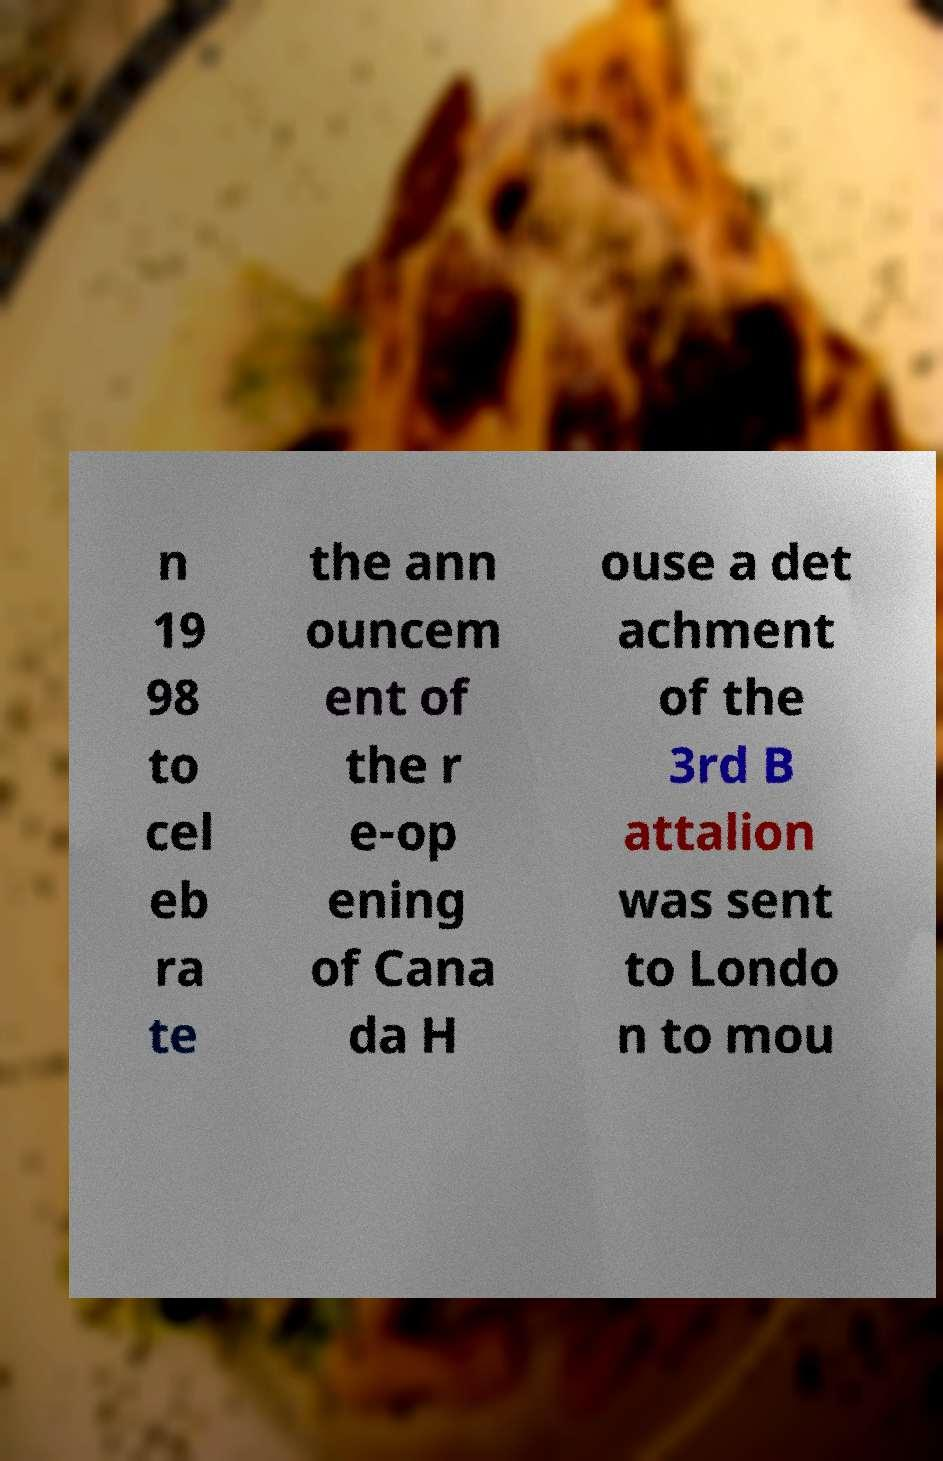There's text embedded in this image that I need extracted. Can you transcribe it verbatim? n 19 98 to cel eb ra te the ann ouncem ent of the r e-op ening of Cana da H ouse a det achment of the 3rd B attalion was sent to Londo n to mou 